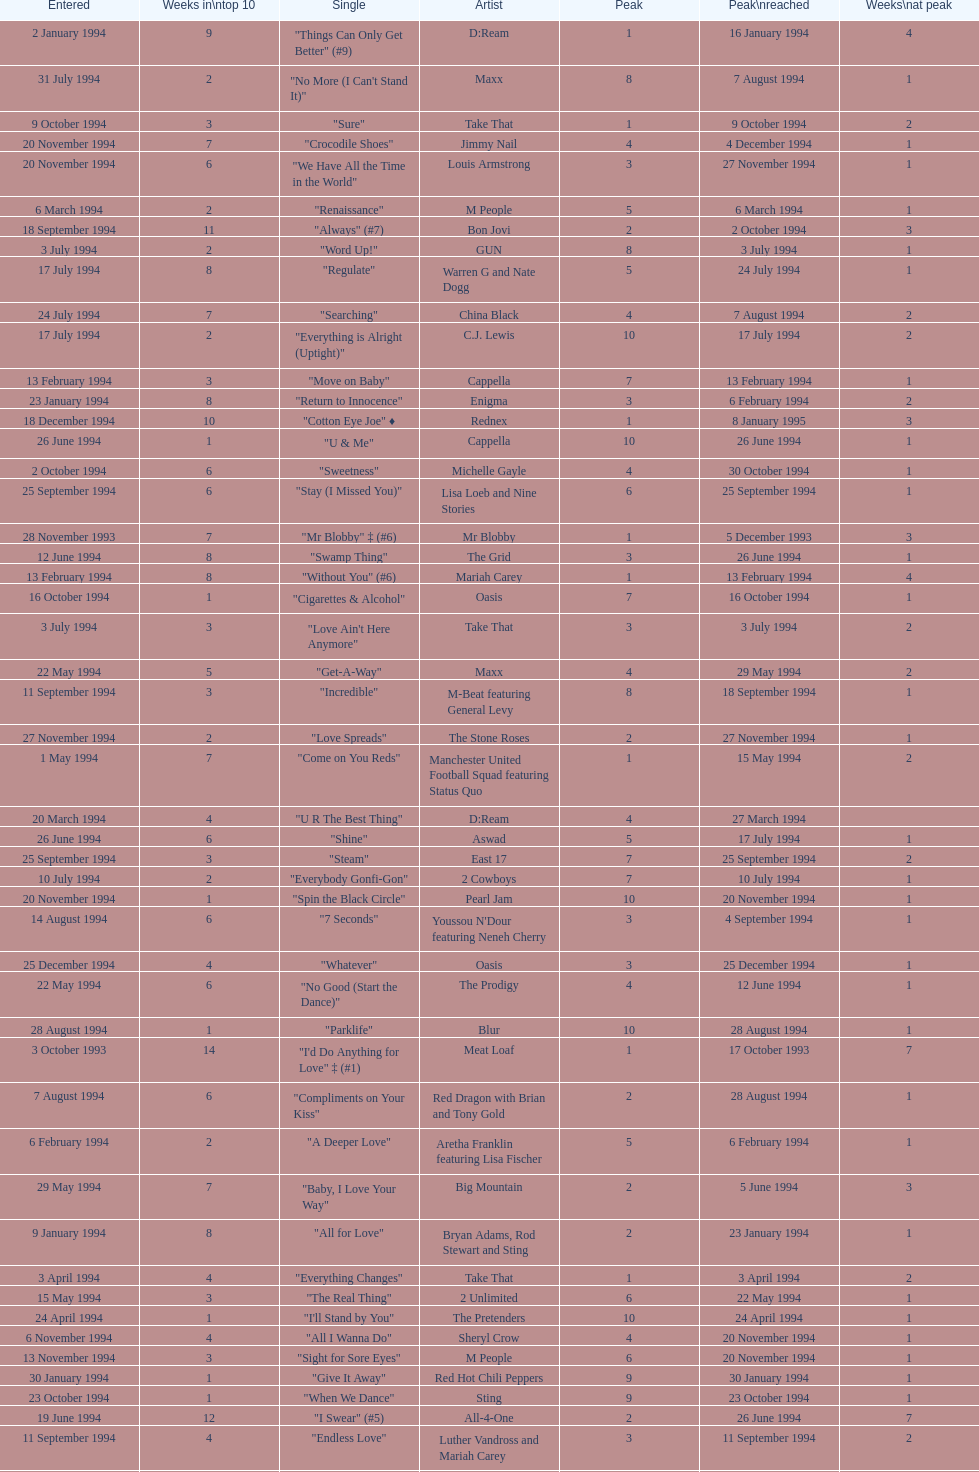Parse the table in full. {'header': ['Entered', 'Weeks in\\ntop 10', 'Single', 'Artist', 'Peak', 'Peak\\nreached', 'Weeks\\nat peak'], 'rows': [['2 January 1994', '9', '"Things Can Only Get Better" (#9)', 'D:Ream', '1', '16 January 1994', '4'], ['31 July 1994', '2', '"No More (I Can\'t Stand It)"', 'Maxx', '8', '7 August 1994', '1'], ['9 October 1994', '3', '"Sure"', 'Take That', '1', '9 October 1994', '2'], ['20 November 1994', '7', '"Crocodile Shoes"', 'Jimmy Nail', '4', '4 December 1994', '1'], ['20 November 1994', '6', '"We Have All the Time in the World"', 'Louis Armstrong', '3', '27 November 1994', '1'], ['6 March 1994', '2', '"Renaissance"', 'M People', '5', '6 March 1994', '1'], ['18 September 1994', '11', '"Always" (#7)', 'Bon Jovi', '2', '2 October 1994', '3'], ['3 July 1994', '2', '"Word Up!"', 'GUN', '8', '3 July 1994', '1'], ['17 July 1994', '8', '"Regulate"', 'Warren G and Nate Dogg', '5', '24 July 1994', '1'], ['24 July 1994', '7', '"Searching"', 'China Black', '4', '7 August 1994', '2'], ['17 July 1994', '2', '"Everything is Alright (Uptight)"', 'C.J. Lewis', '10', '17 July 1994', '2'], ['13 February 1994', '3', '"Move on Baby"', 'Cappella', '7', '13 February 1994', '1'], ['23 January 1994', '8', '"Return to Innocence"', 'Enigma', '3', '6 February 1994', '2'], ['18 December 1994', '10', '"Cotton Eye Joe" ♦', 'Rednex', '1', '8 January 1995', '3'], ['26 June 1994', '1', '"U & Me"', 'Cappella', '10', '26 June 1994', '1'], ['2 October 1994', '6', '"Sweetness"', 'Michelle Gayle', '4', '30 October 1994', '1'], ['25 September 1994', '6', '"Stay (I Missed You)"', 'Lisa Loeb and Nine Stories', '6', '25 September 1994', '1'], ['28 November 1993', '7', '"Mr Blobby" ‡ (#6)', 'Mr Blobby', '1', '5 December 1993', '3'], ['12 June 1994', '8', '"Swamp Thing"', 'The Grid', '3', '26 June 1994', '1'], ['13 February 1994', '8', '"Without You" (#6)', 'Mariah Carey', '1', '13 February 1994', '4'], ['16 October 1994', '1', '"Cigarettes & Alcohol"', 'Oasis', '7', '16 October 1994', '1'], ['3 July 1994', '3', '"Love Ain\'t Here Anymore"', 'Take That', '3', '3 July 1994', '2'], ['22 May 1994', '5', '"Get-A-Way"', 'Maxx', '4', '29 May 1994', '2'], ['11 September 1994', '3', '"Incredible"', 'M-Beat featuring General Levy', '8', '18 September 1994', '1'], ['27 November 1994', '2', '"Love Spreads"', 'The Stone Roses', '2', '27 November 1994', '1'], ['1 May 1994', '7', '"Come on You Reds"', 'Manchester United Football Squad featuring Status Quo', '1', '15 May 1994', '2'], ['20 March 1994', '4', '"U R The Best Thing"', 'D:Ream', '4', '27 March 1994', ''], ['26 June 1994', '6', '"Shine"', 'Aswad', '5', '17 July 1994', '1'], ['25 September 1994', '3', '"Steam"', 'East 17', '7', '25 September 1994', '2'], ['10 July 1994', '2', '"Everybody Gonfi-Gon"', '2 Cowboys', '7', '10 July 1994', '1'], ['20 November 1994', '1', '"Spin the Black Circle"', 'Pearl Jam', '10', '20 November 1994', '1'], ['14 August 1994', '6', '"7 Seconds"', "Youssou N'Dour featuring Neneh Cherry", '3', '4 September 1994', '1'], ['25 December 1994', '4', '"Whatever"', 'Oasis', '3', '25 December 1994', '1'], ['22 May 1994', '6', '"No Good (Start the Dance)"', 'The Prodigy', '4', '12 June 1994', '1'], ['28 August 1994', '1', '"Parklife"', 'Blur', '10', '28 August 1994', '1'], ['3 October 1993', '14', '"I\'d Do Anything for Love" ‡ (#1)', 'Meat Loaf', '1', '17 October 1993', '7'], ['7 August 1994', '6', '"Compliments on Your Kiss"', 'Red Dragon with Brian and Tony Gold', '2', '28 August 1994', '1'], ['6 February 1994', '2', '"A Deeper Love"', 'Aretha Franklin featuring Lisa Fischer', '5', '6 February 1994', '1'], ['29 May 1994', '7', '"Baby, I Love Your Way"', 'Big Mountain', '2', '5 June 1994', '3'], ['9 January 1994', '8', '"All for Love"', 'Bryan Adams, Rod Stewart and Sting', '2', '23 January 1994', '1'], ['3 April 1994', '4', '"Everything Changes"', 'Take That', '1', '3 April 1994', '2'], ['15 May 1994', '3', '"The Real Thing"', '2 Unlimited', '6', '22 May 1994', '1'], ['24 April 1994', '1', '"I\'ll Stand by You"', 'The Pretenders', '10', '24 April 1994', '1'], ['6 November 1994', '4', '"All I Wanna Do"', 'Sheryl Crow', '4', '20 November 1994', '1'], ['13 November 1994', '3', '"Sight for Sore Eyes"', 'M People', '6', '20 November 1994', '1'], ['30 January 1994', '1', '"Give It Away"', 'Red Hot Chili Peppers', '9', '30 January 1994', '1'], ['23 October 1994', '1', '"When We Dance"', 'Sting', '9', '23 October 1994', '1'], ['19 June 1994', '12', '"I Swear" (#5)', 'All-4-One', '2', '26 June 1994', '7'], ['11 September 1994', '4', '"Endless Love"', 'Luther Vandross and Mariah Carey', '3', '11 September 1994', '2'], ['16 January 1994', '3', '"I Miss You"', 'Haddaway', '9', '16 January 1994', '1'], ['19 December 1993', '3', '"Bat Out of Hell" ‡', 'Meat Loaf', '8', '19 December 1993', '2'], ['27 February 1994', '1', '"Don\'t Go Breaking My Heart"', 'Elton John and RuPaul', '7', '27 February 1994', '1'], ['18 December 1994', '4', '"Them Girls, Them Girls" ♦', 'Zig and Zag', '5', '1 January 1995', '1'], ['11 December 1994', '2', '"Please Come Home for Christmas"', 'Bon Jovi', '7', '11 December 1994', '1'], ['1 May 1994', '2', '"Light My Fire"', 'Clubhouse featuring Carl', '7', '1 May 1994', '1'], ['5 June 1994', '3', '"Absolutely Fabulous"', 'Absolutely Fabulous', '6', '12 June 1994', '1'], ['16 January 1994', '3', '"Cornflake Girl"', 'Tori Amos', '4', '23 January 1994', '1'], ['17 April 1994', '3', '"Dedicated to the One I Love"', 'Bitty McLean', '6', '24 April 1994', '1'], ['6 February 1994', '1', '"Sweet Lullaby"', 'Deep Forest', '10', '6 February 1994', '1'], ['8 May 1994', '5', '"Around the World"', 'East 17', '3', '15 May 1994', '2'], ['17 April 1994', '4', '"Always"', 'Erasure', '4', '17 April 1994', '2'], ['31 July 1994', '4', '"Let\'s Get Ready to Rhumble"', 'PJ & Duncan', '1', '31 March 2013', '1'], ['4 December 1994', '5', '"All I Want for Christmas Is You"', 'Mariah Carey', '2', '11 December 1994', '3'], ['26 December 1993', '7', '"Come Baby Come"', 'K7', '3', '16 January 1994', '2'], ['6 February 1994', '11', '"I Like to Move It"', 'Reel 2 Real featuring The Mad Stuntman', '5', '27 March 1994', '1'], ['14 August 1994', '2', '"Live Forever"', 'Oasis', '10', '14 August 1994', '2'], ['13 March 1994', '2', '"Girls & Boys"', 'Blur', '5', '13 March 1994', '1'], ['16 January 1994', '1', '"Here I Stand"', 'Bitty McLean', '10', '16 January 1994', '1'], ['21 August 1994', '1', '"Eighteen Strings"', 'Tinman', '9', '21 August 1994', '1'], ['4 December 1994', '17', '"Think Twice" ♦', 'Celine Dion', '1', '29 January 1995', '7'], ['28 August 1994', '5', '"I\'ll Make Love to You"', 'Boyz II Men', '5', '4 September 1994', '1'], ['1 May 1994', '6', '"Inside"', 'Stiltskin', '1', '8 May 1994', '1'], ['11 December 1994', '2', '"Another Day" ♦', 'Whigfield', '7', '1 January 1995', '1'], ['13 February 1994', '4', '"Let the Beat Control Your Body"', '2 Unlimited', '6', '27 February 1994', '1'], ['4 September 1994', '3', '"Confide in Me"', 'Kylie Minogue', '2', '4 September 1994', '1'], ['10 April 1994', '6', '"The Real Thing"', 'Tony Di Bart', '1', '1 May 1994', '1'], ['7 August 1994', '4', '"What\'s Up?"', 'DJ Miko', '6', '14 August 1994', '1'], ['11 September 1994', '2', '"What\'s the Frequency, Kenneth"', 'R.E.M.', '9', '11 September 1994', '1'], ['16 October 1994', '4', '"Welcome to Tomorrow (Are You Ready?)"', 'Snap! featuring Summer', '6', '30 October 1994', '1'], ['13 March 1994', '7', '"Streets of Philadelphia"', 'Bruce Springsteen', '2', '27 March 1994', '1'], ['29 May 1994', '1', '"Carry Me Home"', 'Gloworm', '9', '29 May 1994', '1'], ['6 November 1994', '5', '"Another Night"', 'MC Sar and Real McCoy', '2', '13 November 1994', '1'], ['6 February 1994', '1', '"Come In Out of the Rain"', 'Wendy Moten', '8', '6 February 1994', '1'], ['20 March 1994', '3', '"Whatta Man"', 'Salt-N-Pepa with En Vogue', '7', '20 March 1994', '1'], ['12 June 1994', '3', '"Don\'t Turn Around"', 'Ace of Base', '5', '19 June 1994', '1'], ['23 January 1994', '1', '"In Your Room"', 'Depeche Mode', '8', '23 January 1994', '1'], ['13 November 1994', '1', '"True Faith \'94"', 'New Order', '9', '13 November 1994', '1'], ['20 March 1994', '2', '"Shine On"', 'Degrees of Motion featuring Biti', '8', '27 March 1994', '1'], ['15 May 1994', '2', '"More to This World"', 'Bad Boys Inc', '8', '22 May 1994', '1'], ['8 May 1994', '3', '"Just a Step from Heaven"', 'Eternal', '8', '15 May 1994', '1'], ['12 December 1993', '5', '"The Perfect Year"', 'Dina Carroll', '5', '2 January 1994', '1'], ['2 October 1994', '10', '"Baby Come Back" (#4)', 'Pato Banton featuring Ali and Robin Campbell', '1', '23 October 1994', '4'], ['30 October 1994', '2', '"Some Girls"', 'Ultimate Kaos', '9', '30 October 1994', '1'], ['5 June 1994', '1', '"Since I Don\'t Have You"', 'Guns N Roses', '10', '5 June 1994', '1'], ['30 October 1994', '4', '"Oh Baby I..."', 'Eternal', '4', '6 November 1994', '1'], ['30 January 1994', '4', '"The Power of Love"', 'Céline Dion', '4', '6 February 1994', '1'], ['12 December 1993', '7', '"Twist and Shout"', 'Chaka Demus & Pliers featuring Jack Radics and Taxi Gang', '1', '2 January 1994', '2'], ['12 June 1994', '2', '"Anytime You Need a Friend"', 'Mariah Carey', '8', '19 June 1994', '1'], ['13 March 1994', '1', '"Pretty Good Year"', 'Tori Amos', '7', '13 March 1994', '1'], ['17 April 1994', '5', '"Mmm Mmm Mmm Mmm"', 'Crash Test Dummies', '2', '24 April 1994', '1'], ['11 December 1994', '3', '"Power Rangers: The Official Single"', 'The Mighty RAW', '3', '11 December', '1'], ['13 November 1994', '5', '"Let Me Be Your Fantasy"', 'Baby D', '1', '20 November 1994', '2'], ['6 March 1994', '1', '"Rocks" / "Funky Jam"', 'Primal Scream', '7', '6 March 1994', '1'], ['3 July 1994', '7', '"(Meet) The Flintstones"', 'The B.C. 52s', '3', '17 July 1994', '3'], ['4 September 1994', '6', '"The Rhythm of the Night"', 'Corona', '2', '18 September 1994', '2'], ['9 January 1994', '4', '"Anything"', 'Culture Beat', '5', '9 January 1994', '2'], ['24 July 1994', '1', '"Run to the Sun"', 'Erasure', '6', '24 July 1994', '1'], ['26 June 1994', '2', '"Go On Move"', 'Reel 2 Real featuring The Mad Stuntman', '7', '26 June 1994', '2'], ['4 December 1994', '8', '"Love Me for a Reason" ♦', 'Boyzone', '2', '1 January 1995', '1'], ['24 April 1994', '6', '"Sweets for My Sweet"', 'C.J. Lewis', '3', '1 May 1994', '1'], ['15 May 1994', '20', '"Love Is All Around" (#1)', 'Wet Wet Wet', '1', '29 May 1994', '15'], ['12 December 1993', '5', '"Babe" ‡', 'Take That', '1', '12 December 1993', '1'], ['10 July 1994', '9', '"Crazy for You" (#8)', 'Let Loose', '2', '14 August 1994', '2'], ['2 October 1994', '2', '"Secret"', 'Madonna', '5', '2 October 1994', '1'], ['5 December 1993', '7', '"It\'s Alright"', 'East 17', '3', '9 January 1994', '1'], ['16 October 1994', '5', '"She\'s Got That Vibe"', 'R. Kelly', '3', '6 November 1994', '1'], ['6 March 1994', '1', '"The More You Ignore Me, The Closer I Get"', 'Morrissey', '8', '6 March 1994', '1'], ['27 November 1994', '8', '"Stay Another Day" (#3)', 'East 17', '1', '4 December 1994', '5'], ['27 March 1994', '3', '"I\'ll Remember"', 'Madonna', '7', '3 April 1994', '1'], ['25 September 1994', '6', '"Hey Now (Girls Just Want to Have Fun)"', 'Cyndi Lauper', '4', '2 October 1994', '1'], ['11 September 1994', '10', '"Saturday Night" (#2)', 'Whigfield', '1', '11 September 1994', '4'], ['6 March 1994', '6', '"Doop" (#10)', 'Doop', '1', '13 March 1994', '3'], ['3 April 1994', '6', '"The Most Beautiful Girl in the World"', 'Prince', '1', '17 April 1994', '2'], ['20 February 1994', '2', '"Stay Together"', 'Suede', '3', '20 February 1994', '1'], ['5 December 1993', '6', '"For Whom the Bell Tolls" ‡', 'The Bee Gees', '4', '19 December 1993', '2'], ['5 June 1994', '5', '"You Don\'t Love Me (No, No, No)"', 'Dawn Penn', '3', '12 June 1994', '2'], ['20 March 1994', '2', '"Dry County"', 'Bon Jovi', '9', '27 March 1994', '1'], ['20 February 1994', '9', '"The Sign"', 'Ace of Base', '2', '27 February 1994', '3'], ['16 January 1994', '1', '"Save Our Love"', 'Eternal', '8', '16 January 1994', '1'], ['23 January 1994', '8', '"Breathe Again"', 'Toni Braxton', '2', '30 January 1994', '2'], ['10 April 1994', '2', '"Rock My Heart"', 'Haddaway', '9', '10 April 1994', '2']]} What is the first entered date? 3 October 1993. 